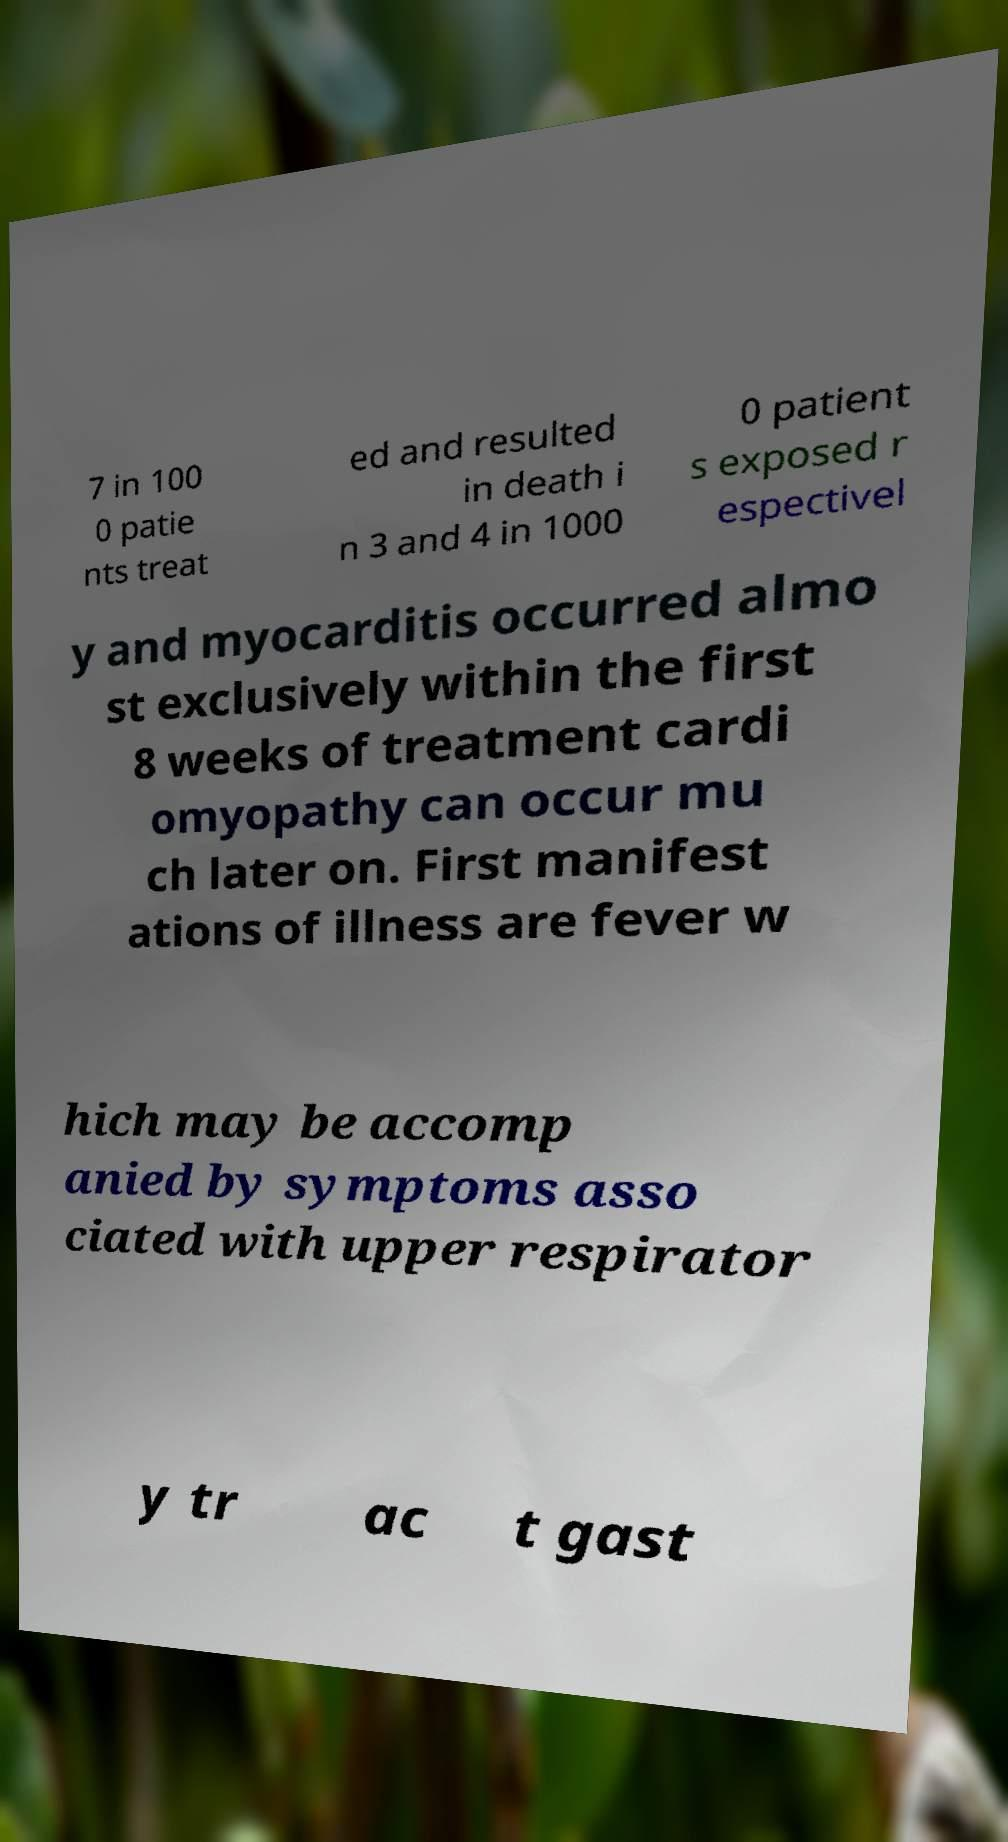For documentation purposes, I need the text within this image transcribed. Could you provide that? 7 in 100 0 patie nts treat ed and resulted in death i n 3 and 4 in 1000 0 patient s exposed r espectivel y and myocarditis occurred almo st exclusively within the first 8 weeks of treatment cardi omyopathy can occur mu ch later on. First manifest ations of illness are fever w hich may be accomp anied by symptoms asso ciated with upper respirator y tr ac t gast 